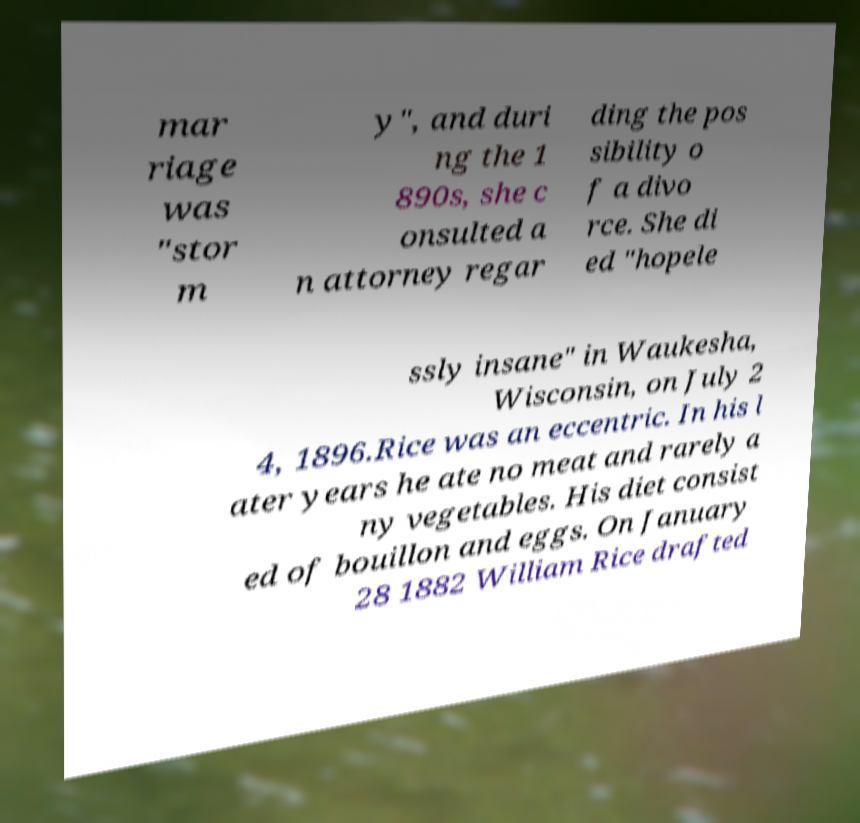Can you read and provide the text displayed in the image?This photo seems to have some interesting text. Can you extract and type it out for me? mar riage was "stor m y", and duri ng the 1 890s, she c onsulted a n attorney regar ding the pos sibility o f a divo rce. She di ed "hopele ssly insane" in Waukesha, Wisconsin, on July 2 4, 1896.Rice was an eccentric. In his l ater years he ate no meat and rarely a ny vegetables. His diet consist ed of bouillon and eggs. On January 28 1882 William Rice drafted 